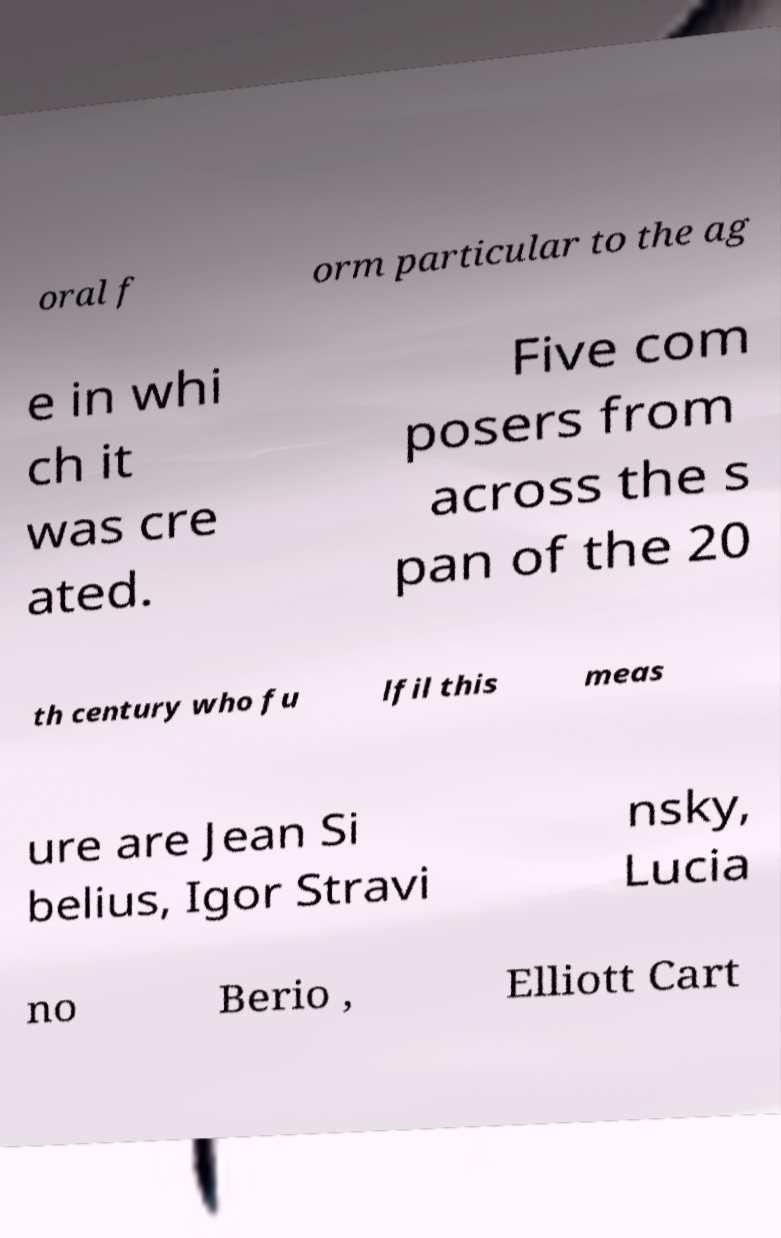What messages or text are displayed in this image? I need them in a readable, typed format. oral f orm particular to the ag e in whi ch it was cre ated. Five com posers from across the s pan of the 20 th century who fu lfil this meas ure are Jean Si belius, Igor Stravi nsky, Lucia no Berio , Elliott Cart 